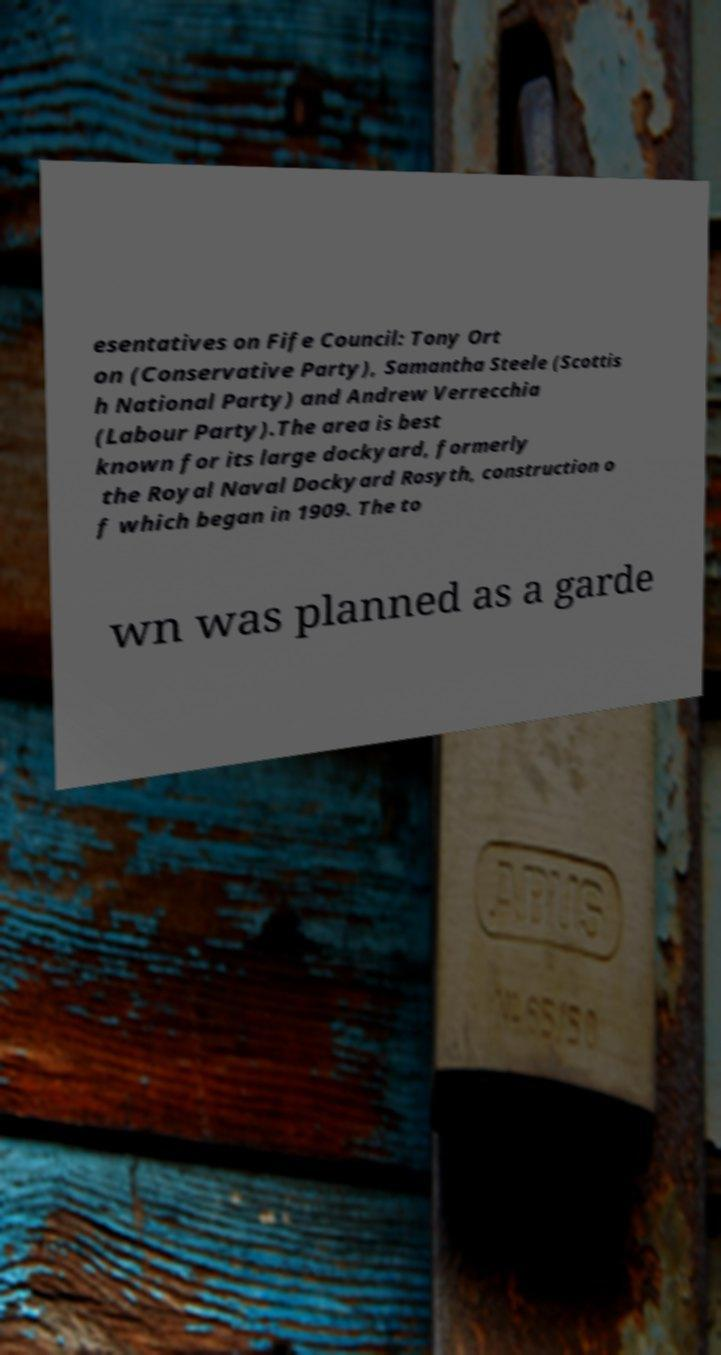Could you extract and type out the text from this image? esentatives on Fife Council: Tony Ort on (Conservative Party), Samantha Steele (Scottis h National Party) and Andrew Verrecchia (Labour Party).The area is best known for its large dockyard, formerly the Royal Naval Dockyard Rosyth, construction o f which began in 1909. The to wn was planned as a garde 